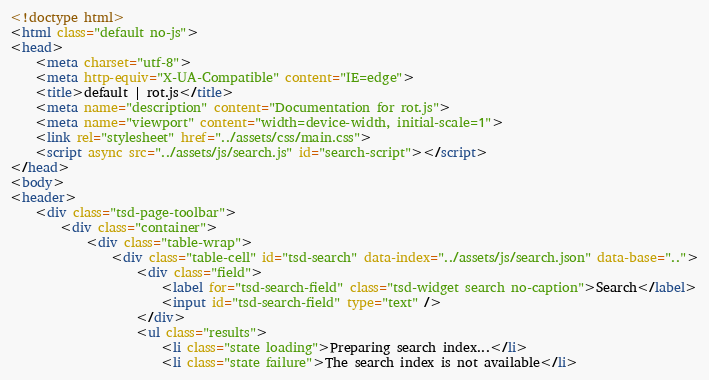Convert code to text. <code><loc_0><loc_0><loc_500><loc_500><_HTML_><!doctype html>
<html class="default no-js">
<head>
	<meta charset="utf-8">
	<meta http-equiv="X-UA-Compatible" content="IE=edge">
	<title>default | rot.js</title>
	<meta name="description" content="Documentation for rot.js">
	<meta name="viewport" content="width=device-width, initial-scale=1">
	<link rel="stylesheet" href="../assets/css/main.css">
	<script async src="../assets/js/search.js" id="search-script"></script>
</head>
<body>
<header>
	<div class="tsd-page-toolbar">
		<div class="container">
			<div class="table-wrap">
				<div class="table-cell" id="tsd-search" data-index="../assets/js/search.json" data-base="..">
					<div class="field">
						<label for="tsd-search-field" class="tsd-widget search no-caption">Search</label>
						<input id="tsd-search-field" type="text" />
					</div>
					<ul class="results">
						<li class="state loading">Preparing search index...</li>
						<li class="state failure">The search index is not available</li></code> 